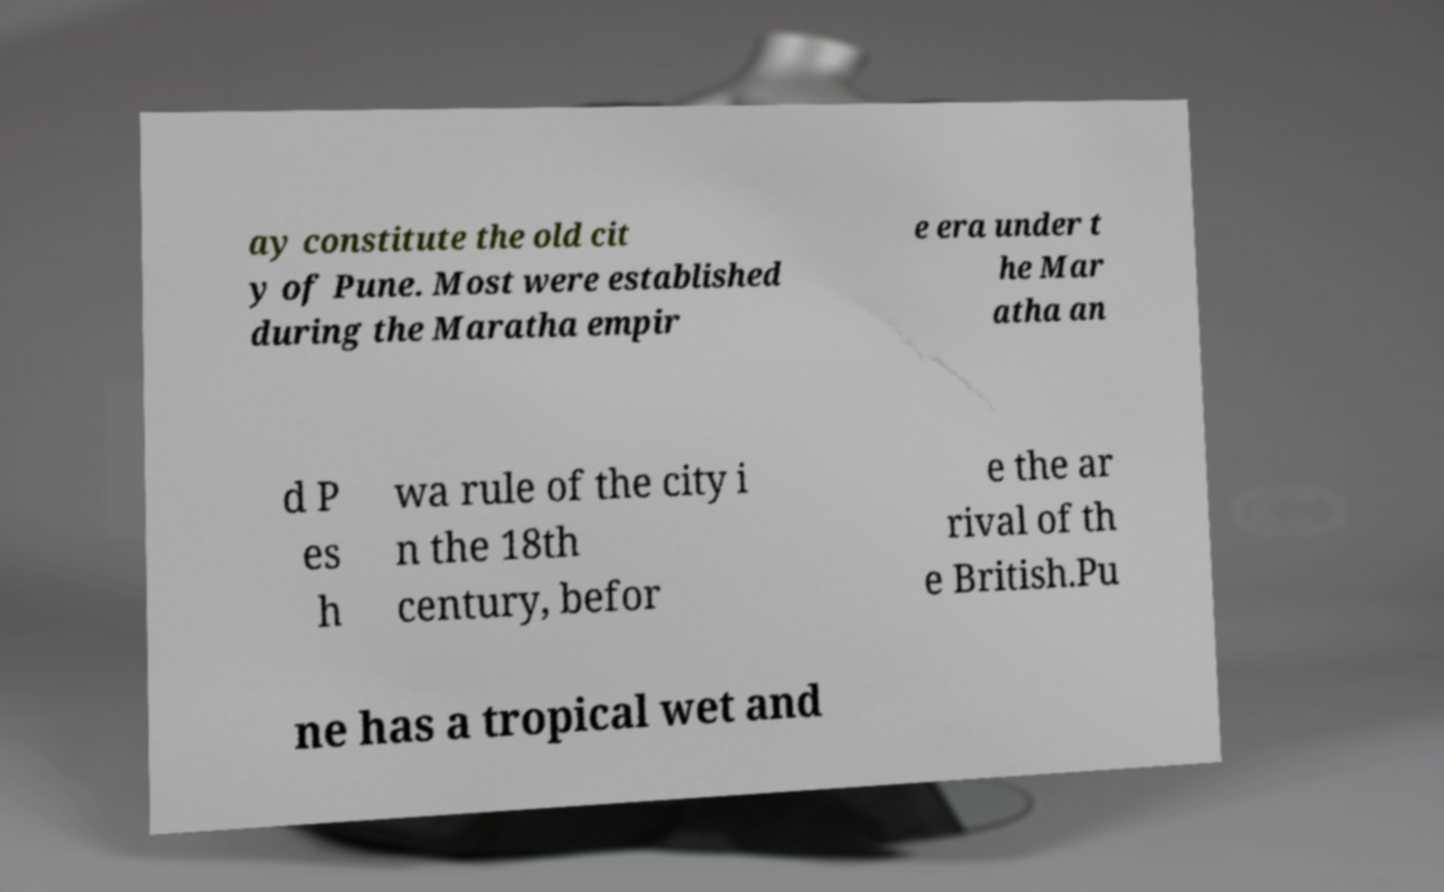Please identify and transcribe the text found in this image. ay constitute the old cit y of Pune. Most were established during the Maratha empir e era under t he Mar atha an d P es h wa rule of the city i n the 18th century, befor e the ar rival of th e British.Pu ne has a tropical wet and 